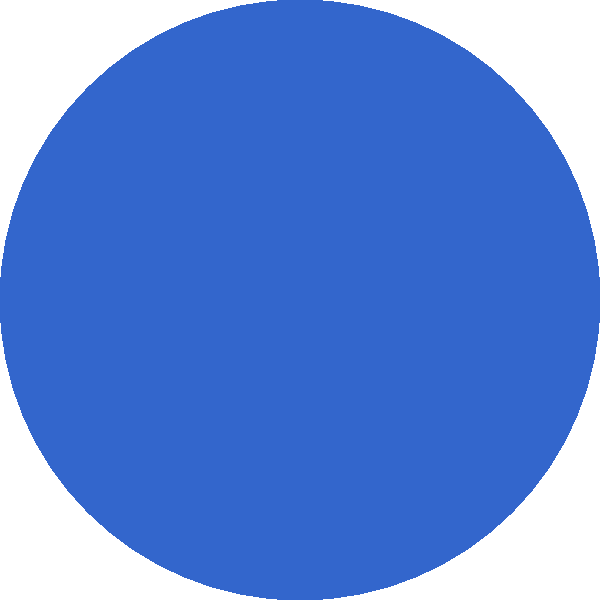In the image above, we see a simplified representation of a nebula. Given your experience with fluid dynamics in petroleum engineering, how might the density distribution within this nebula compare to the density variations you encounter in oil reservoirs? To answer this question, let's consider the following steps:

1. Nebula structure:
   - Nebulae are diffuse clouds of gas and dust in space.
   - They have non-uniform density distributions, with some areas being denser than others.

2. Oil reservoir structure:
   - Oil reservoirs are porous rock formations containing hydrocarbons.
   - They also have varying density distributions due to different rock types and fluid content.

3. Comparison:
   a) Scale: Nebulae are vastly larger than oil reservoirs, but both exhibit density variations.
   b) Fluid dynamics:
      - In nebulae, gravity and radiation pressure influence density distribution.
      - In oil reservoirs, capillary forces, gravity, and pressure gradients affect fluid distribution.
   c) Density gradients:
      - Nebulae: Gradual density changes over large distances.
      - Oil reservoirs: More abrupt changes due to rock layer boundaries.

4. Similarities:
   - Both systems have areas of higher and lower density.
   - Fluid movement occurs in both, albeit at different scales and speeds.

5. Differences:
   - Nebulae are primarily gas, while oil reservoirs contain liquids and gases in porous media.
   - The forces governing density distribution are different in scale and nature.

6. Application of knowledge:
   - Understanding fluid behavior in porous media (reservoirs) can provide insights into larger-scale fluid dynamics (nebulae).
   - Concepts like pressure gradients and fluid flow apply to both systems, though at different scales.
Answer: Both exhibit non-uniform density distributions, but nebulae have more gradual density changes over larger scales compared to the more abrupt changes in oil reservoirs. 